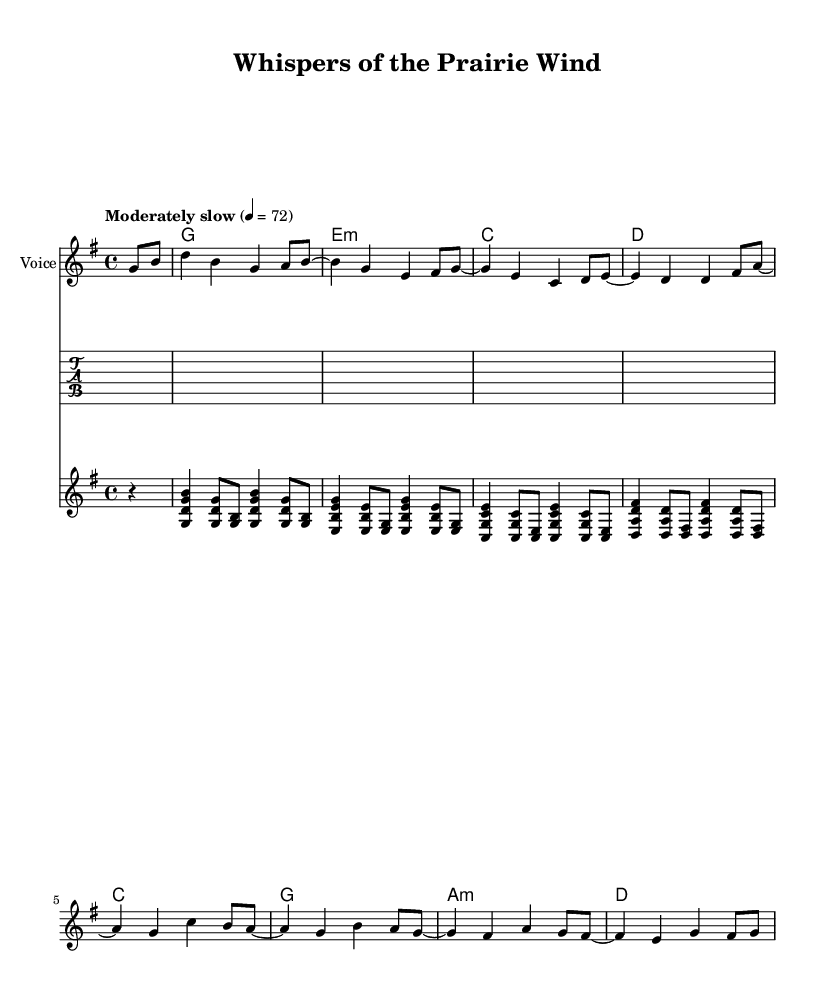What is the key signature of this music? The key signature displayed at the beginning of the score shows one sharp, which indicates that the music is set in G major.
Answer: G major What is the time signature of this piece? The time signature is found at the beginning of the score, which is indicated as four beats per measure. Therefore, the time signature is 4/4.
Answer: 4/4 What is the tempo marking for this piece? The tempo marking is found at the start of the score, indicating that the piece should be played moderately slow at a speed of sixty beats per minute.
Answer: Moderately slow, 72 How many measures are in the guitar part? The guitar part includes segments separated by vertical lines known as bar lines, and by counting these segments, we determine that there are eight measures in total.
Answer: Eight Which chord appears at the beginning of the song? The first chord in the chord section is indicated right after the first silence indicator, showing that the song starts with a G major chord.
Answer: G What kind of picking style is represented in the guitar part? The guitar part includes a pattern of arpeggiated chords played in a picking style, characterized by the specific multiple note placements and voicings used in the measures.
Answer: Fingerpicking What is the final chord of the harmony section? The ending chord is found in the last measure of the harmony section, looking at the chord names and identifying that the last one displayed is a D major chord.
Answer: D 